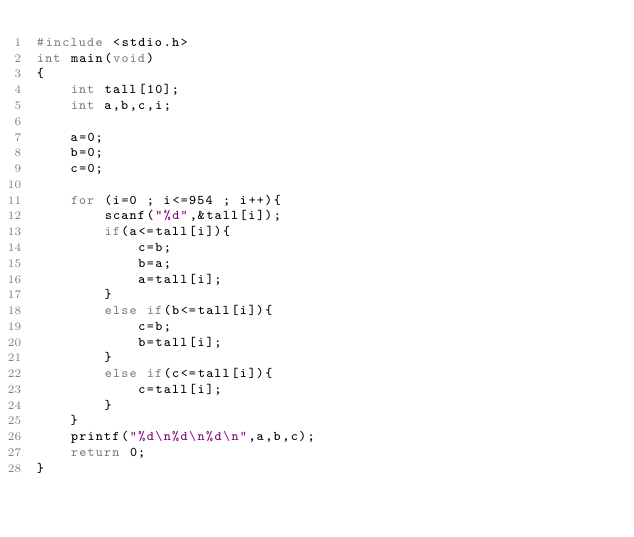<code> <loc_0><loc_0><loc_500><loc_500><_C_>#include <stdio.h>
int main(void)
{
	int tall[10];
	int a,b,c,i;

	a=0;
	b=0;
	c=0;

	for (i=0 ; i<=954 ; i++){
		scanf("%d",&tall[i]);
		if(a<=tall[i]){
			c=b;
			b=a;
			a=tall[i];
		}
		else if(b<=tall[i]){
			c=b;
			b=tall[i];
		}
		else if(c<=tall[i]){
			c=tall[i];
		}
	}
	printf("%d\n%d\n%d\n",a,b,c);
	return 0;
}</code> 